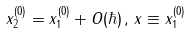Convert formula to latex. <formula><loc_0><loc_0><loc_500><loc_500>x _ { 2 } ^ { ( 0 ) } = x _ { 1 } ^ { ( 0 ) } + O ( \hbar { ) } \, , \, x \equiv x _ { 1 } ^ { ( 0 ) }</formula> 